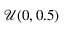Convert formula to latex. <formula><loc_0><loc_0><loc_500><loc_500>\mathcal { U } ( 0 , 0 . 5 )</formula> 